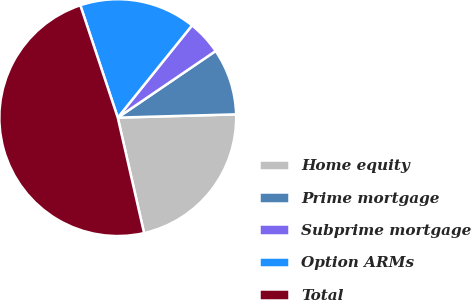Convert chart. <chart><loc_0><loc_0><loc_500><loc_500><pie_chart><fcel>Home equity<fcel>Prime mortgage<fcel>Subprime mortgage<fcel>Option ARMs<fcel>Total<nl><fcel>21.87%<fcel>9.07%<fcel>4.7%<fcel>15.91%<fcel>48.45%<nl></chart> 